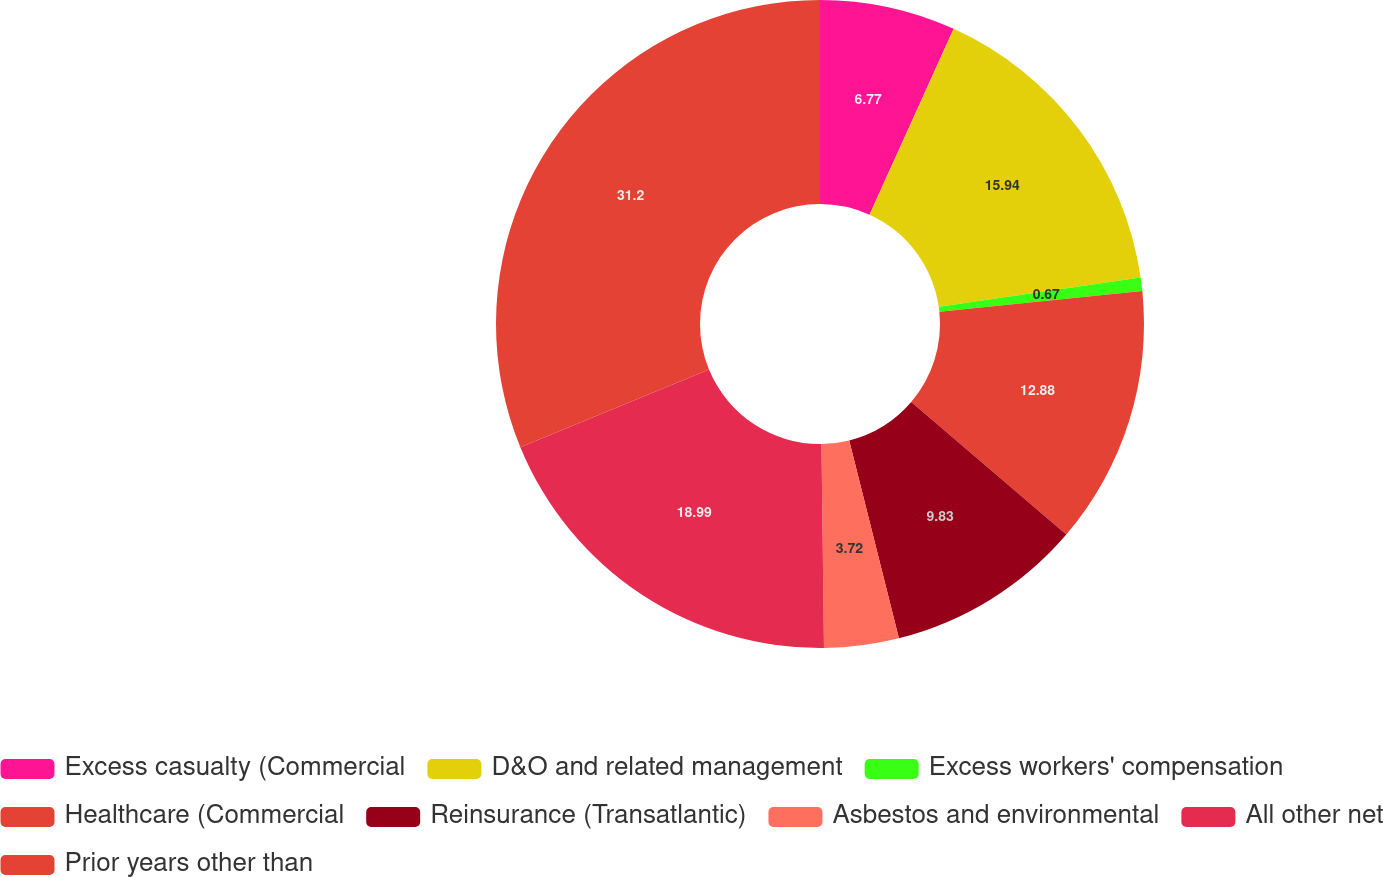Convert chart. <chart><loc_0><loc_0><loc_500><loc_500><pie_chart><fcel>Excess casualty (Commercial<fcel>D&O and related management<fcel>Excess workers' compensation<fcel>Healthcare (Commercial<fcel>Reinsurance (Transatlantic)<fcel>Asbestos and environmental<fcel>All other net<fcel>Prior years other than<nl><fcel>6.77%<fcel>15.94%<fcel>0.67%<fcel>12.88%<fcel>9.83%<fcel>3.72%<fcel>18.99%<fcel>31.21%<nl></chart> 